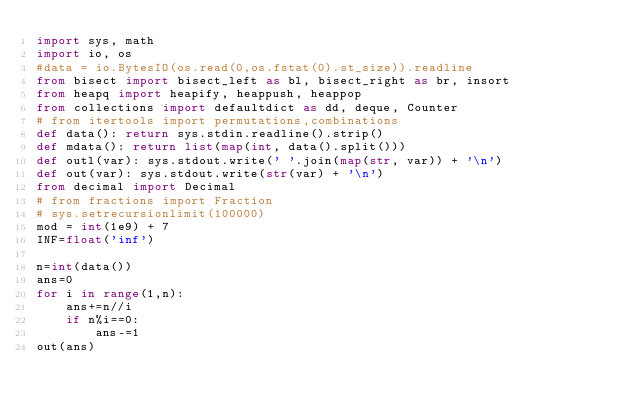Convert code to text. <code><loc_0><loc_0><loc_500><loc_500><_Python_>import sys, math
import io, os
#data = io.BytesIO(os.read(0,os.fstat(0).st_size)).readline
from bisect import bisect_left as bl, bisect_right as br, insort
from heapq import heapify, heappush, heappop
from collections import defaultdict as dd, deque, Counter
# from itertools import permutations,combinations
def data(): return sys.stdin.readline().strip()
def mdata(): return list(map(int, data().split()))
def outl(var): sys.stdout.write(' '.join(map(str, var)) + '\n')
def out(var): sys.stdout.write(str(var) + '\n')
from decimal import Decimal
# from fractions import Fraction
# sys.setrecursionlimit(100000)
mod = int(1e9) + 7
INF=float('inf')

n=int(data())
ans=0
for i in range(1,n):
    ans+=n//i
    if n%i==0:
        ans-=1
out(ans)</code> 